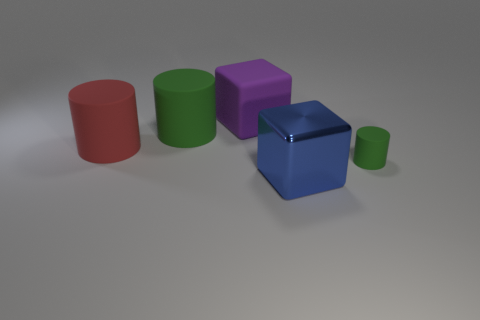Add 2 big matte cylinders. How many objects exist? 7 Subtract all blocks. How many objects are left? 3 Subtract all purple objects. Subtract all tiny brown rubber blocks. How many objects are left? 4 Add 5 large blue cubes. How many large blue cubes are left? 6 Add 1 large cyan metallic cubes. How many large cyan metallic cubes exist? 1 Subtract 0 blue cylinders. How many objects are left? 5 